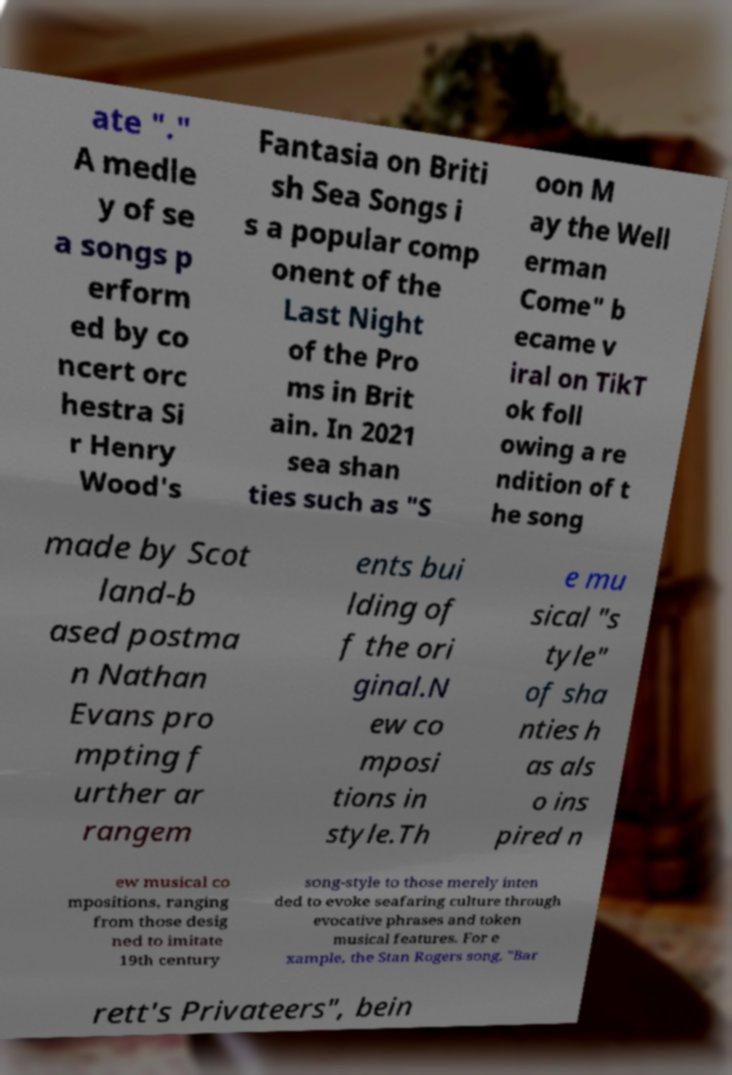Can you read and provide the text displayed in the image?This photo seems to have some interesting text. Can you extract and type it out for me? ate "." A medle y of se a songs p erform ed by co ncert orc hestra Si r Henry Wood's Fantasia on Briti sh Sea Songs i s a popular comp onent of the Last Night of the Pro ms in Brit ain. In 2021 sea shan ties such as "S oon M ay the Well erman Come" b ecame v iral on TikT ok foll owing a re ndition of t he song made by Scot land-b ased postma n Nathan Evans pro mpting f urther ar rangem ents bui lding of f the ori ginal.N ew co mposi tions in style.Th e mu sical "s tyle" of sha nties h as als o ins pired n ew musical co mpositions, ranging from those desig ned to imitate 19th century song-style to those merely inten ded to evoke seafaring culture through evocative phrases and token musical features. For e xample, the Stan Rogers song, "Bar rett's Privateers", bein 